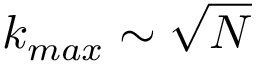<formula> <loc_0><loc_0><loc_500><loc_500>k _ { \max } \sim \sqrt { N }</formula> 